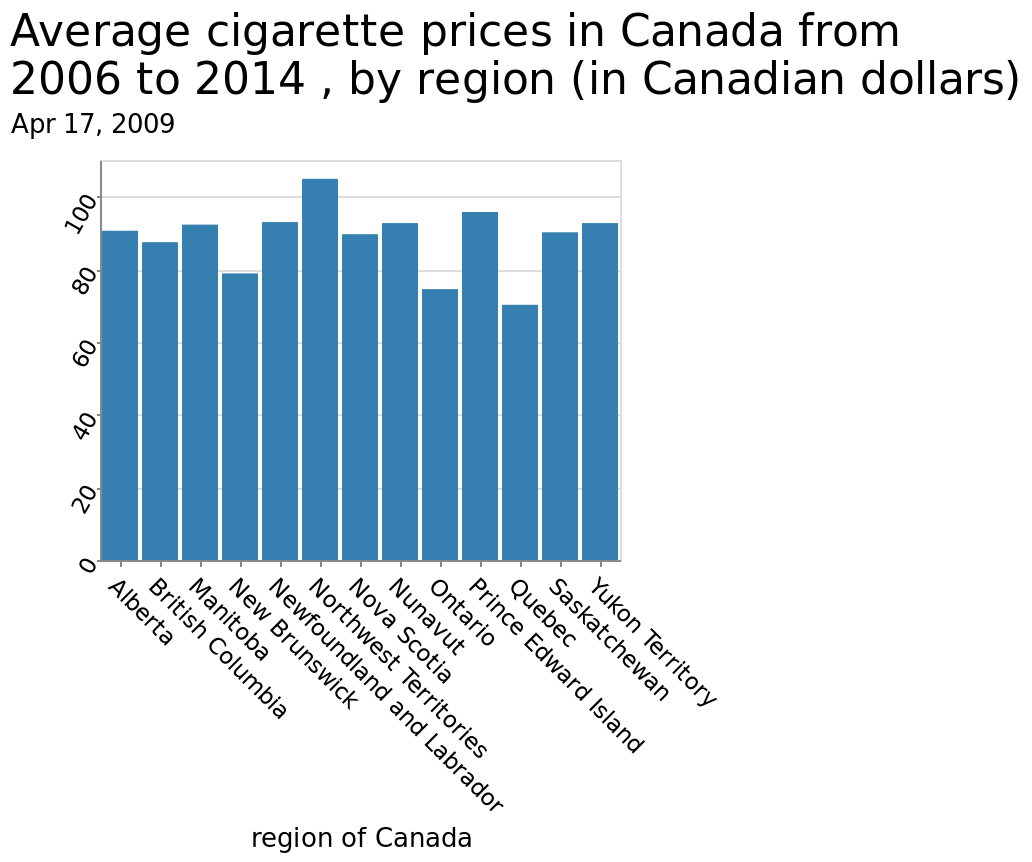<image>
What does the x-axis represent in the bar chart?  The x-axis represents the different regions of Canada. please summary the statistics and relations of the chart Each region has a relatively similar number of cigarette prices to each other, the highest average price coming from the Northwest territories and the least coming from Quebec. The Northwest territories is the only region where the average price is more than 100. What does the y-axis measure in the bar chart?  The y-axis measures the average cigarette prices in Canada from 2006 to 2014. 